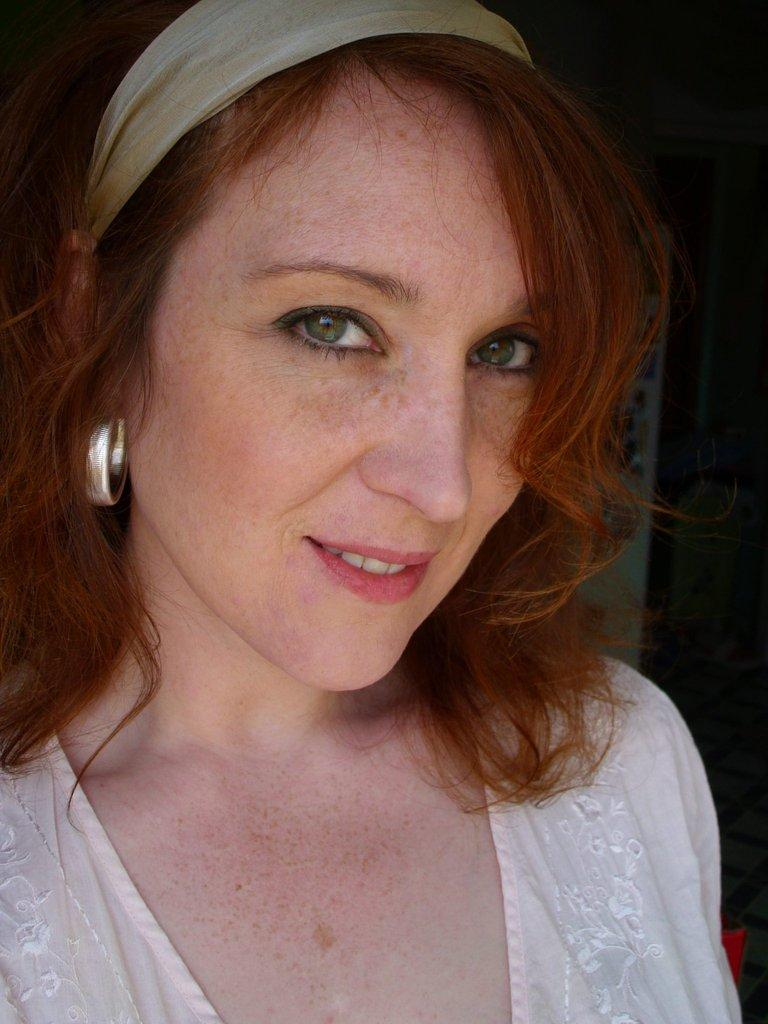Who is present in the image? There is a woman in the image. What is the woman doing in the image? The woman is smiling. How many brothers does the woman have in the image? There is no information about the woman's brothers in the image. 